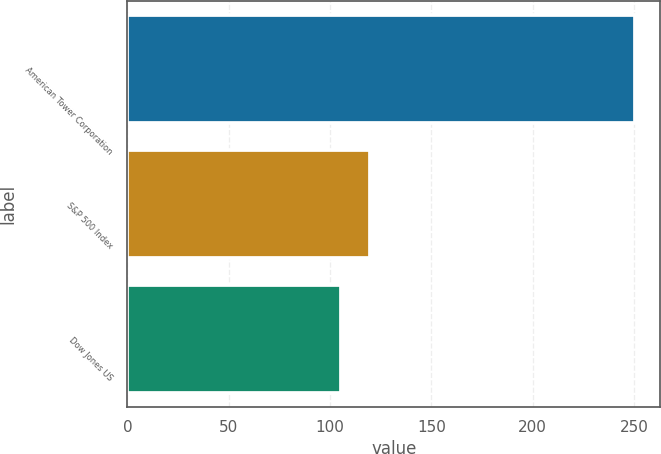<chart> <loc_0><loc_0><loc_500><loc_500><bar_chart><fcel>American Tower Corporation<fcel>S&P 500 Index<fcel>Dow Jones US<nl><fcel>250.46<fcel>119.78<fcel>105.26<nl></chart> 